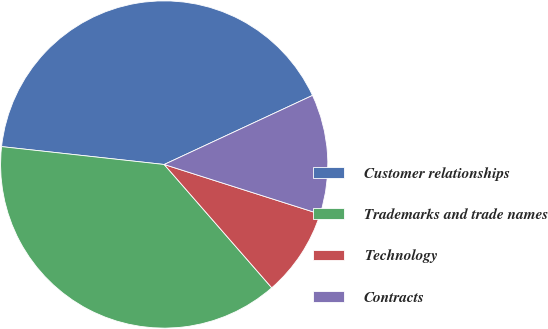Convert chart. <chart><loc_0><loc_0><loc_500><loc_500><pie_chart><fcel>Customer relationships<fcel>Trademarks and trade names<fcel>Technology<fcel>Contracts<nl><fcel>41.32%<fcel>38.16%<fcel>8.68%<fcel>11.84%<nl></chart> 